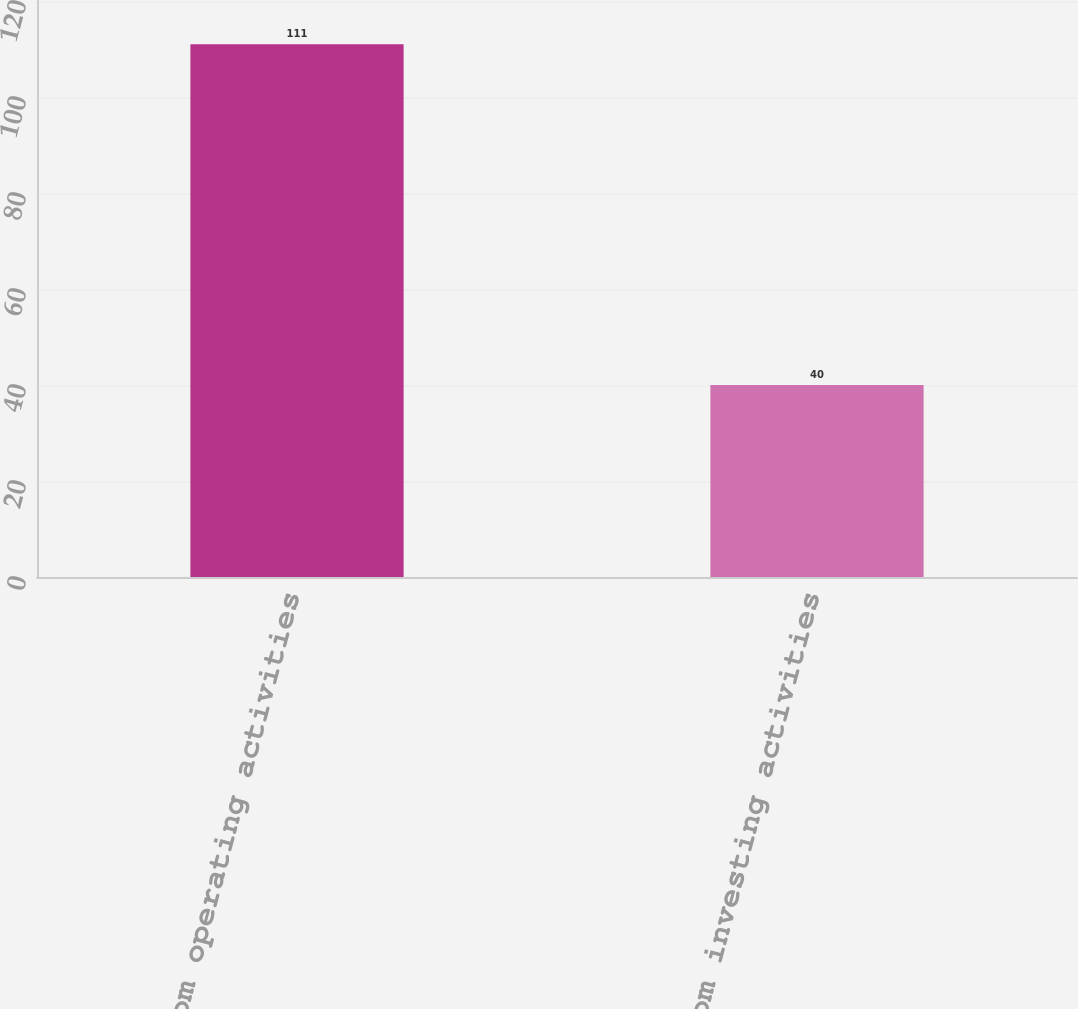Convert chart. <chart><loc_0><loc_0><loc_500><loc_500><bar_chart><fcel>Cash from operating activities<fcel>Cash from investing activities<nl><fcel>111<fcel>40<nl></chart> 